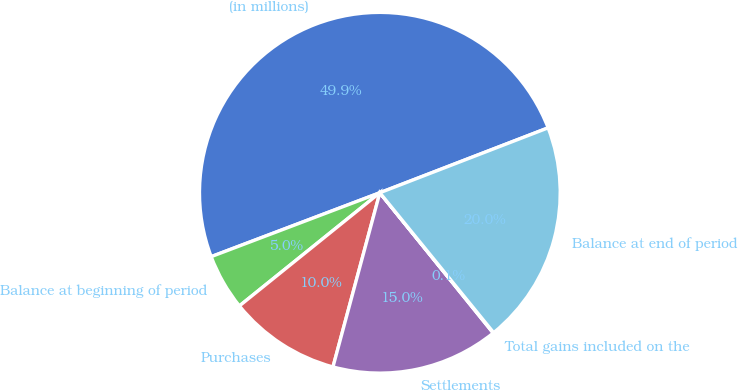<chart> <loc_0><loc_0><loc_500><loc_500><pie_chart><fcel>(in millions)<fcel>Balance at beginning of period<fcel>Purchases<fcel>Settlements<fcel>Total gains included on the<fcel>Balance at end of period<nl><fcel>49.9%<fcel>5.03%<fcel>10.02%<fcel>15.0%<fcel>0.05%<fcel>19.99%<nl></chart> 